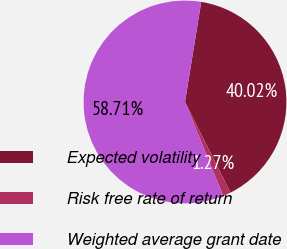Convert chart to OTSL. <chart><loc_0><loc_0><loc_500><loc_500><pie_chart><fcel>Expected volatility<fcel>Risk free rate of return<fcel>Weighted average grant date<nl><fcel>40.02%<fcel>1.27%<fcel>58.7%<nl></chart> 